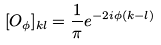<formula> <loc_0><loc_0><loc_500><loc_500>[ O _ { \phi } ] _ { k l } = \frac { 1 } { \pi } e ^ { - 2 i \phi ( k - l ) }</formula> 